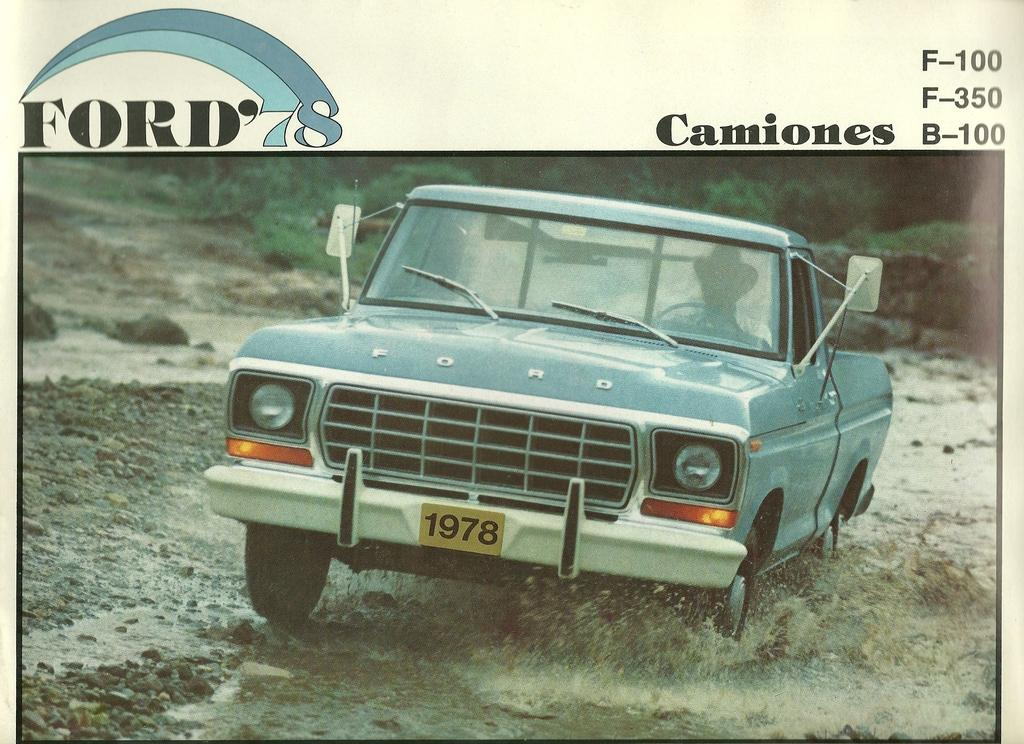What type of visual is the image? The image is a poster. What is the main subject of the poster? There is a car in the poster. What elements are present in the background of the poster? There is mud, water, stones, and plants in the poster. Is there any text in the poster? Yes, there is text in the poster. How many stitches are visible on the car in the poster? There are no stitches visible on the car in the poster, as it is a two-dimensional image and not a physical object. 